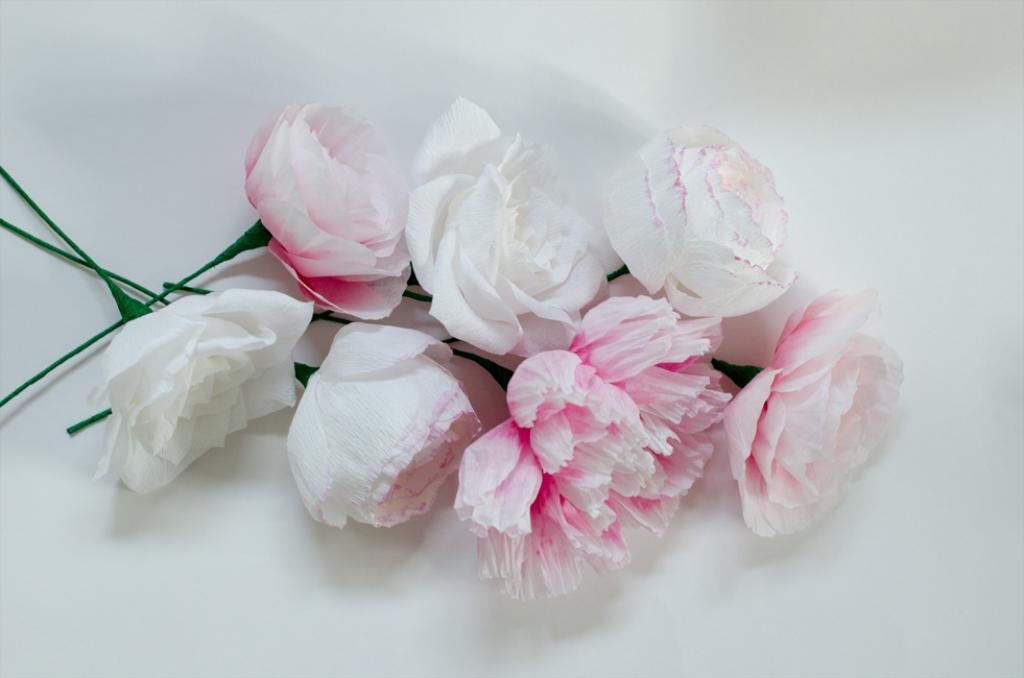What is present in the image? There are flowers in the image. What is the color of the surface where the flowers are placed? The flowers are on a white surface. What colors can be seen in the flowers? The flowers are in white and pink colors. How many pizzas are hidden among the flowers in the image? There are no pizzas present in the image; it only features flowers on a white surface. 